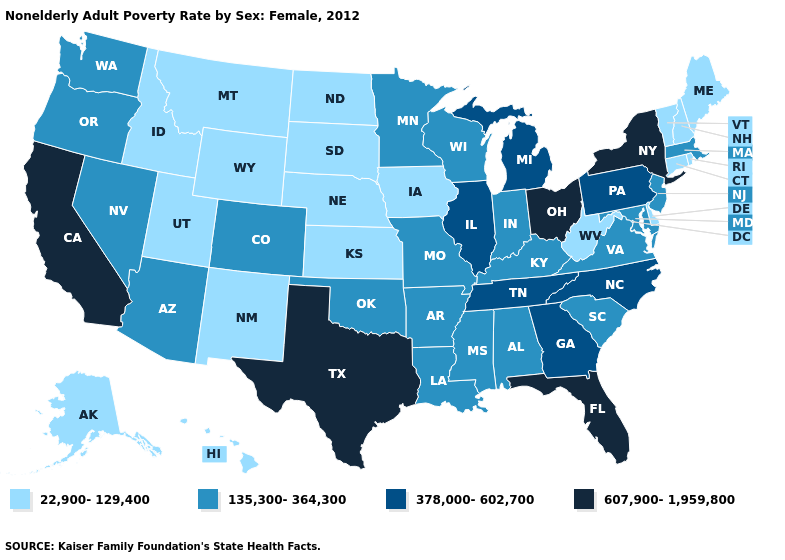Does the map have missing data?
Answer briefly. No. Name the states that have a value in the range 22,900-129,400?
Write a very short answer. Alaska, Connecticut, Delaware, Hawaii, Idaho, Iowa, Kansas, Maine, Montana, Nebraska, New Hampshire, New Mexico, North Dakota, Rhode Island, South Dakota, Utah, Vermont, West Virginia, Wyoming. Among the states that border Rhode Island , which have the lowest value?
Quick response, please. Connecticut. Among the states that border New Hampshire , does Massachusetts have the lowest value?
Short answer required. No. What is the lowest value in the Northeast?
Concise answer only. 22,900-129,400. Which states have the highest value in the USA?
Quick response, please. California, Florida, New York, Ohio, Texas. Which states have the highest value in the USA?
Quick response, please. California, Florida, New York, Ohio, Texas. What is the value of Kansas?
Short answer required. 22,900-129,400. What is the highest value in states that border New Hampshire?
Concise answer only. 135,300-364,300. Name the states that have a value in the range 135,300-364,300?
Be succinct. Alabama, Arizona, Arkansas, Colorado, Indiana, Kentucky, Louisiana, Maryland, Massachusetts, Minnesota, Mississippi, Missouri, Nevada, New Jersey, Oklahoma, Oregon, South Carolina, Virginia, Washington, Wisconsin. Which states have the lowest value in the West?
Answer briefly. Alaska, Hawaii, Idaho, Montana, New Mexico, Utah, Wyoming. Among the states that border North Carolina , does South Carolina have the highest value?
Answer briefly. No. How many symbols are there in the legend?
Give a very brief answer. 4. Does Virginia have a lower value than Hawaii?
Concise answer only. No. What is the lowest value in the USA?
Keep it brief. 22,900-129,400. 